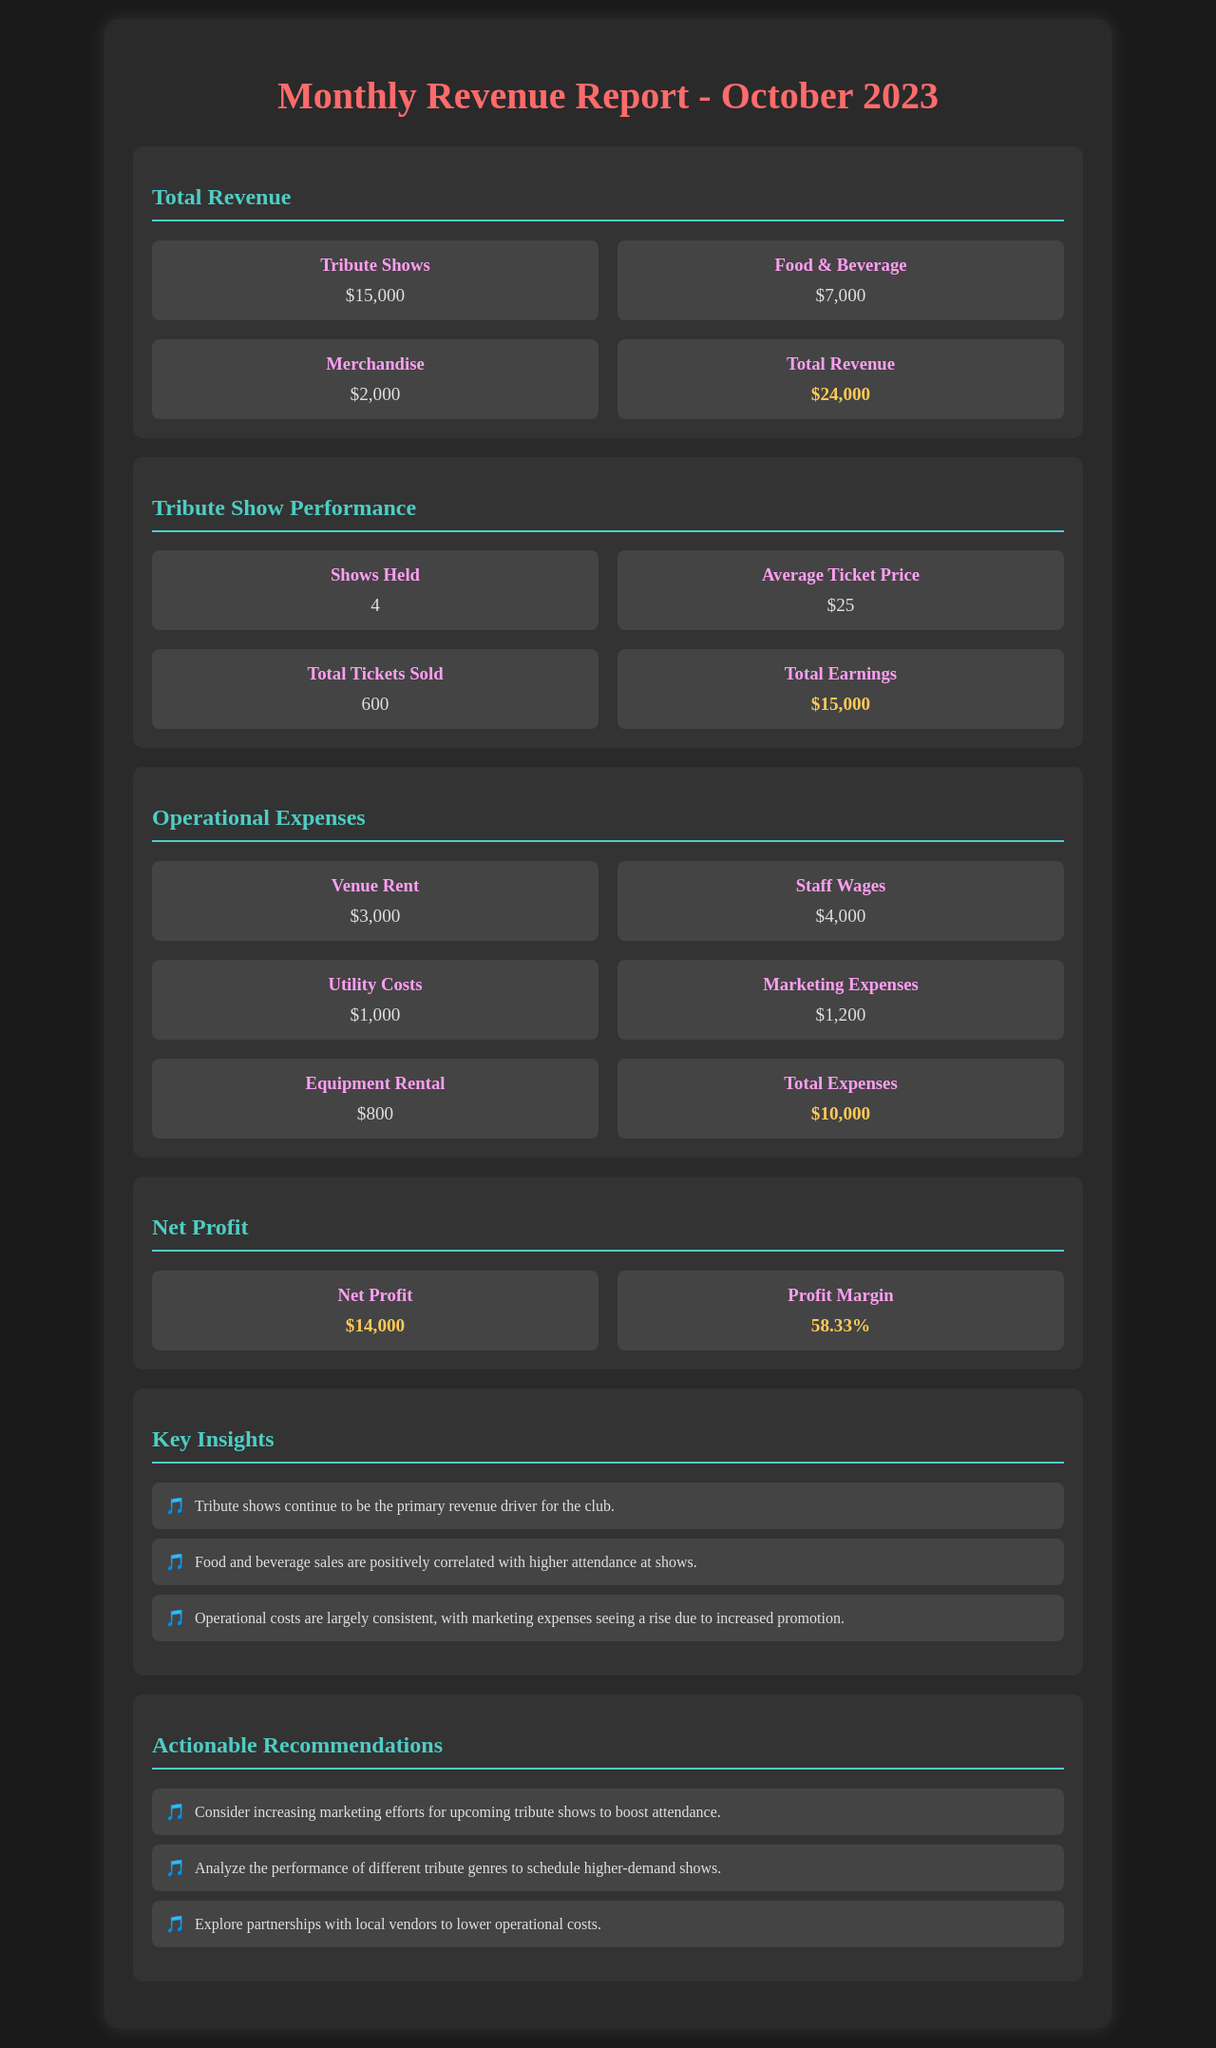what is the total revenue? The total revenue is provided in the document as a sum of all revenue sources: $15,000 (Tribute Shows) + $7,000 (Food & Beverage) + $2,000 (Merchandise) = $24,000.
Answer: $24,000 how many tribute shows were held? The document states that 4 tribute shows were held during October 2023.
Answer: 4 what was the total earnings from tribute shows? The total earnings from tribute shows is specifically highlighted in the document as $15,000.
Answer: $15,000 what were the operational expenses? The total operational expenses are calculated based on the listed expenses in the document: Venue Rent, Staff Wages, Utility Costs, Marketing Expenses, and Equipment Rental, totaling $10,000.
Answer: $10,000 what is the profit margin? The profit margin is calculated from the net profit relative to total revenue, given in the document as 58.33%.
Answer: 58.33% how many tickets were sold? The document indicates that a total of 600 tickets were sold for the tribute shows in October 2023.
Answer: 600 what is the average ticket price? The average ticket price for the tribute shows is mentioned in the document as $25.
Answer: $25 which revenue source contributed the most? The document clearly highlights that tribute shows contributed the most to the total revenue, amounting to $15,000.
Answer: Tribute Shows what marketing expenses are noted? The marketing expenses listed in the report are $1,200, which is part of the operational expenses section.
Answer: $1,200 